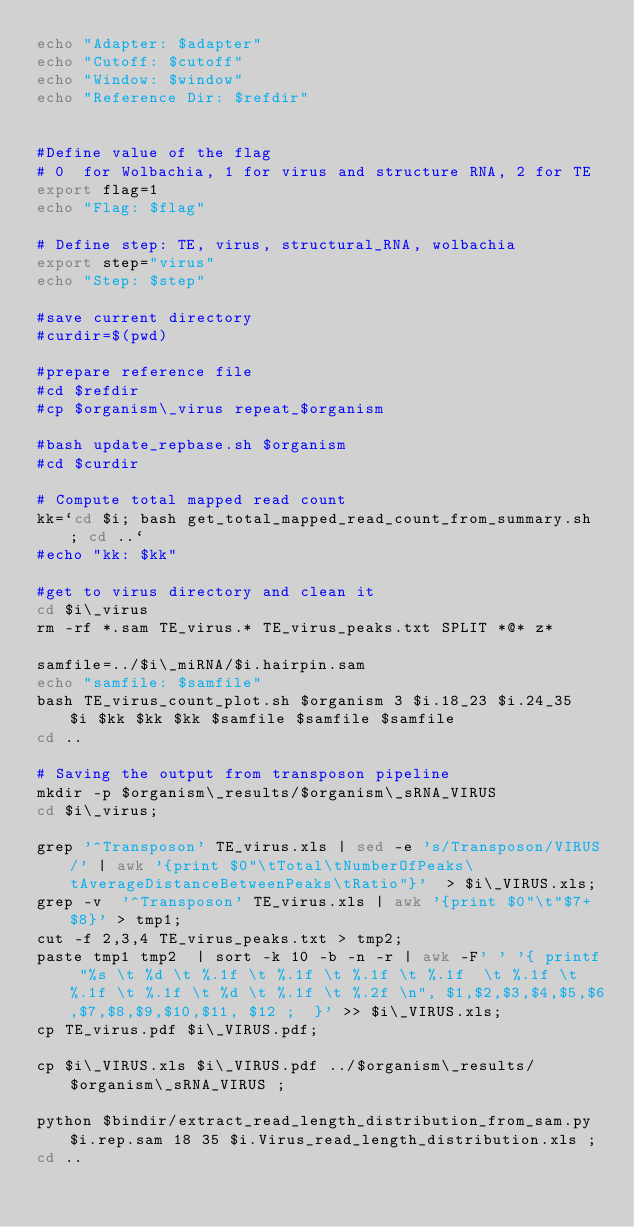Convert code to text. <code><loc_0><loc_0><loc_500><loc_500><_Bash_>echo "Adapter: $adapter"
echo "Cutoff: $cutoff"
echo "Window: $window"
echo "Reference Dir: $refdir"


#Define value of the flag
# 0  for Wolbachia, 1 for virus and structure RNA, 2 for TE
export flag=1 
echo "Flag: $flag"

# Define step: TE, virus, structural_RNA, wolbachia
export step="virus"
echo "Step: $step"

#save current directory
#curdir=$(pwd)

#prepare reference file
#cd $refdir
#cp $organism\_virus repeat_$organism

#bash update_repbase.sh $organism
#cd $curdir

# Compute total mapped read count
kk=`cd $i; bash get_total_mapped_read_count_from_summary.sh ; cd ..` 
#echo "kk: $kk"

#get to virus directory and clean it
cd $i\_virus
rm -rf *.sam TE_virus.* TE_virus_peaks.txt SPLIT *@* z*

samfile=../$i\_miRNA/$i.hairpin.sam
echo "samfile: $samfile"
bash TE_virus_count_plot.sh $organism 3 $i.18_23 $i.24_35  $i $kk $kk $kk $samfile $samfile $samfile
cd ..

# Saving the output from transposon pipeline
mkdir -p $organism\_results/$organism\_sRNA_VIRUS
cd $i\_virus;  

grep '^Transposon' TE_virus.xls | sed -e 's/Transposon/VIRUS/' | awk '{print $0"\tTotal\tNumberOfPeaks\tAverageDistanceBetweenPeaks\tRatio"}'  > $i\_VIRUS.xls; 
grep -v  '^Transposon' TE_virus.xls | awk '{print $0"\t"$7+$8}' > tmp1; 
cut -f 2,3,4 TE_virus_peaks.txt > tmp2; 
paste tmp1 tmp2  | sort -k 10 -b -n -r | awk -F' ' '{ printf "%s \t %d \t %.1f \t %.1f \t %.1f \t %.1f  \t %.1f \t %.1f \t %.1f \t %d \t %.1f \t %.2f \n", $1,$2,$3,$4,$5,$6,$7,$8,$9,$10,$11, $12 ;  }' >> $i\_VIRUS.xls;  
cp TE_virus.pdf $i\_VIRUS.pdf;

cp $i\_VIRUS.xls $i\_VIRUS.pdf ../$organism\_results/$organism\_sRNA_VIRUS ; 

python $bindir/extract_read_length_distribution_from_sam.py $i.rep.sam 18 35 $i.Virus_read_length_distribution.xls ; 
cd ..
</code> 